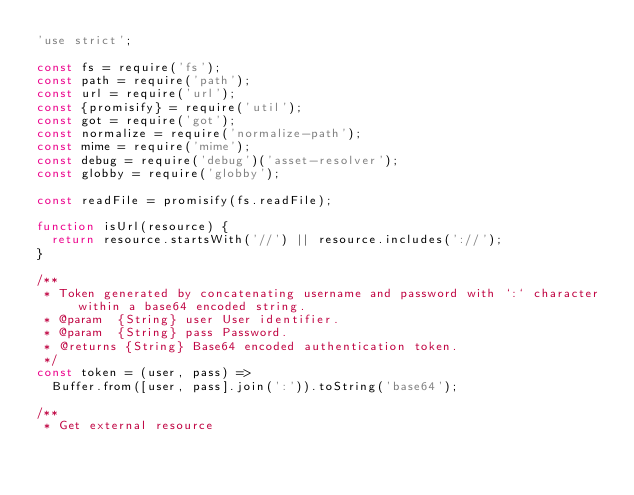Convert code to text. <code><loc_0><loc_0><loc_500><loc_500><_JavaScript_>'use strict';

const fs = require('fs');
const path = require('path');
const url = require('url');
const {promisify} = require('util');
const got = require('got');
const normalize = require('normalize-path');
const mime = require('mime');
const debug = require('debug')('asset-resolver');
const globby = require('globby');

const readFile = promisify(fs.readFile);

function isUrl(resource) {
  return resource.startsWith('//') || resource.includes('://');
}

/**
 * Token generated by concatenating username and password with `:` character within a base64 encoded string.
 * @param  {String} user User identifier.
 * @param  {String} pass Password.
 * @returns {String} Base64 encoded authentication token.
 */
const token = (user, pass) =>
  Buffer.from([user, pass].join(':')).toString('base64');

/**
 * Get external resource</code> 